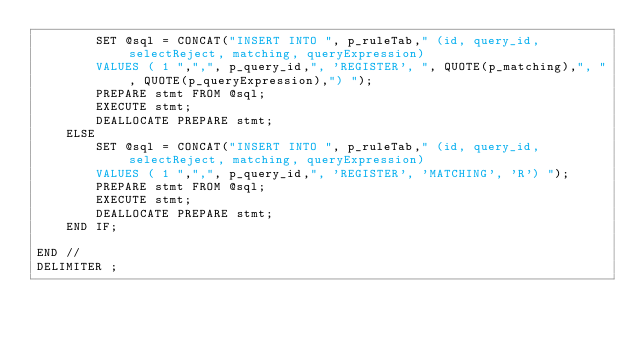Convert code to text. <code><loc_0><loc_0><loc_500><loc_500><_SQL_>        SET @sql = CONCAT("INSERT INTO ", p_ruleTab," (id, query_id, selectReject, matching, queryExpression) 
        VALUES ( 1 ",",", p_query_id,", 'REGISTER', ", QUOTE(p_matching),", ", QUOTE(p_queryExpression),") ");
        PREPARE stmt FROM @sql;
        EXECUTE stmt;
        DEALLOCATE PREPARE stmt;
    ELSE
        SET @sql = CONCAT("INSERT INTO ", p_ruleTab," (id, query_id, selectReject, matching, queryExpression) 
        VALUES ( 1 ",",", p_query_id,", 'REGISTER', 'MATCHING', 'R') ");
        PREPARE stmt FROM @sql;
        EXECUTE stmt;
        DEALLOCATE PREPARE stmt;
    END IF;

END //
DELIMITER ;
</code> 